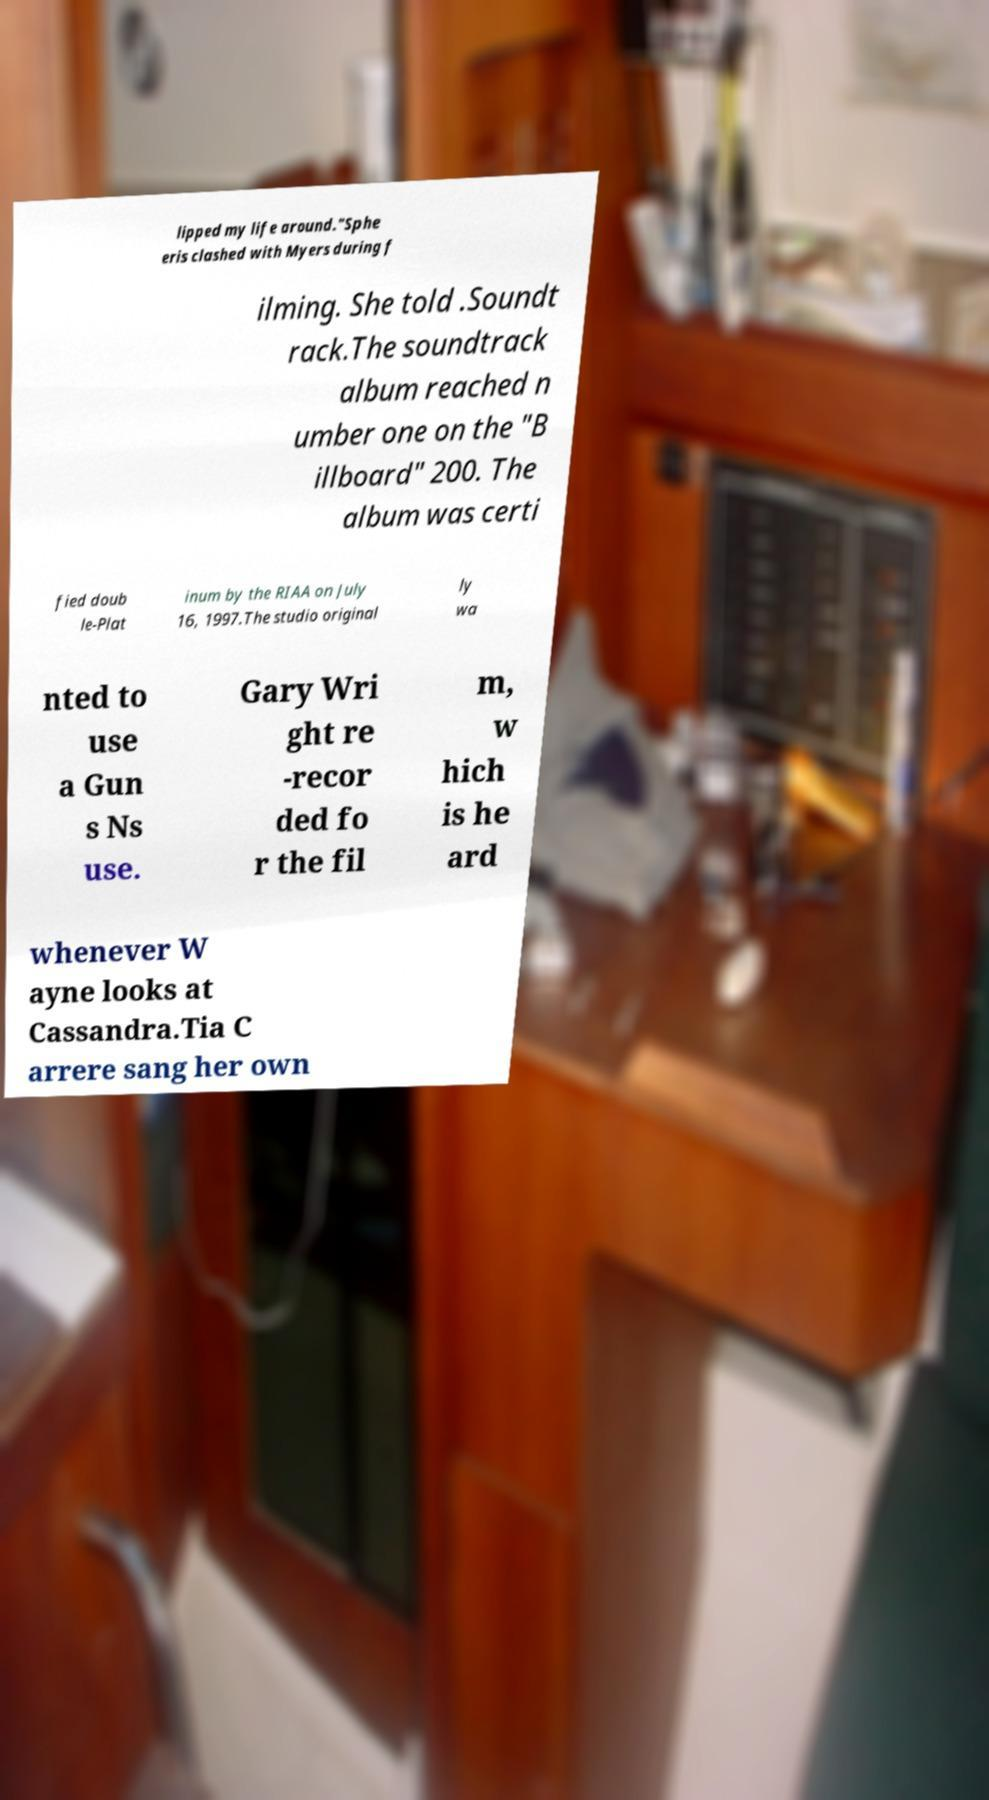I need the written content from this picture converted into text. Can you do that? lipped my life around."Sphe eris clashed with Myers during f ilming. She told .Soundt rack.The soundtrack album reached n umber one on the "B illboard" 200. The album was certi fied doub le-Plat inum by the RIAA on July 16, 1997.The studio original ly wa nted to use a Gun s Ns use. Gary Wri ght re -recor ded fo r the fil m, w hich is he ard whenever W ayne looks at Cassandra.Tia C arrere sang her own 